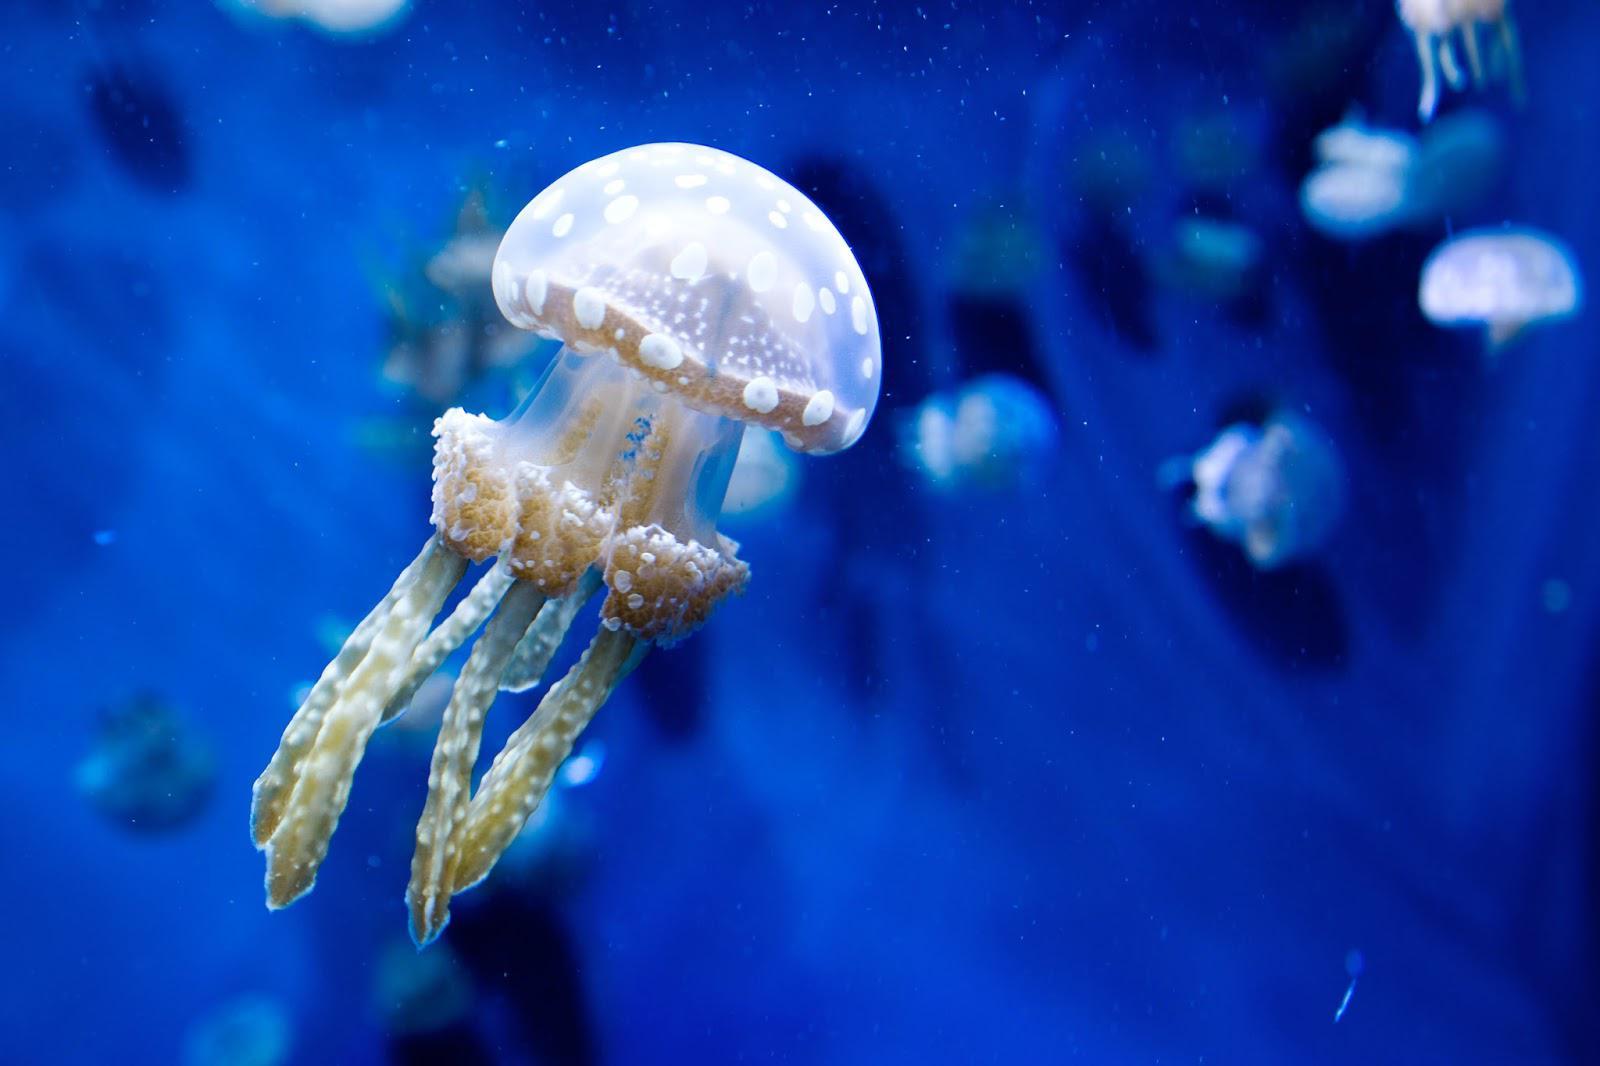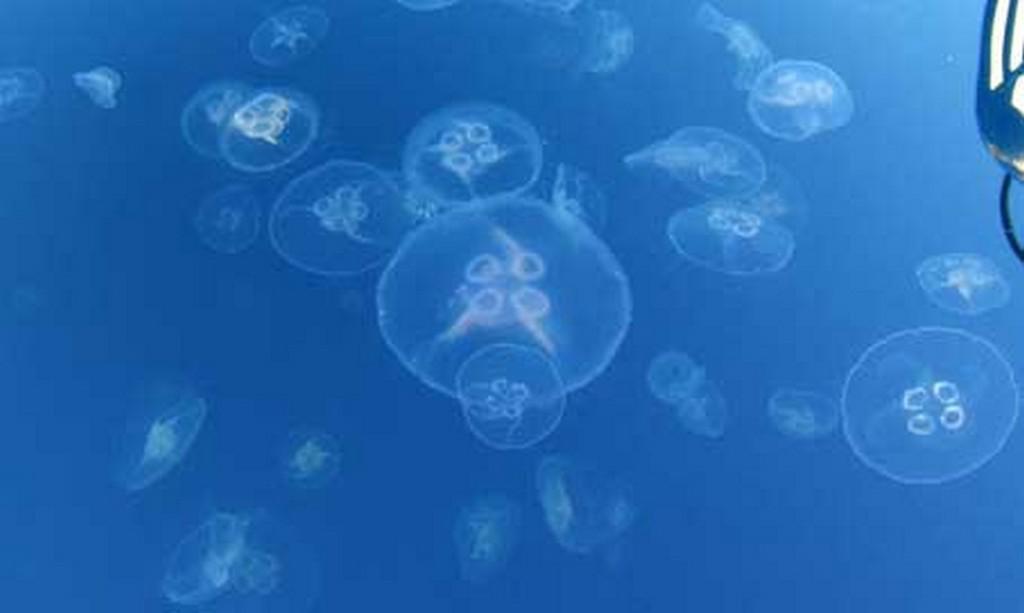The first image is the image on the left, the second image is the image on the right. Examine the images to the left and right. Is the description "The surface of the water is visible." accurate? Answer yes or no. No. The first image is the image on the left, the second image is the image on the right. Examine the images to the left and right. Is the description "One of the images has a person in the lwater with the sting rays." accurate? Answer yes or no. No. 